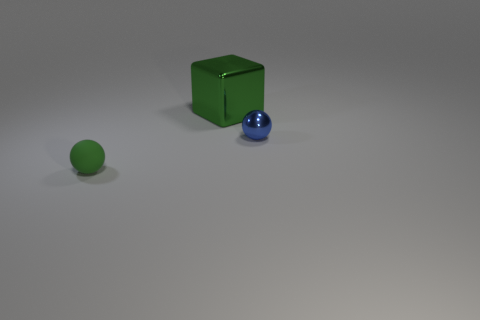What textures are present on the surfaces of the objects? The surfaces of the objects appear to have a smooth texture with some light reflections, indicating a possibly metallic or polished finish, especially noticeable on the sphere. 